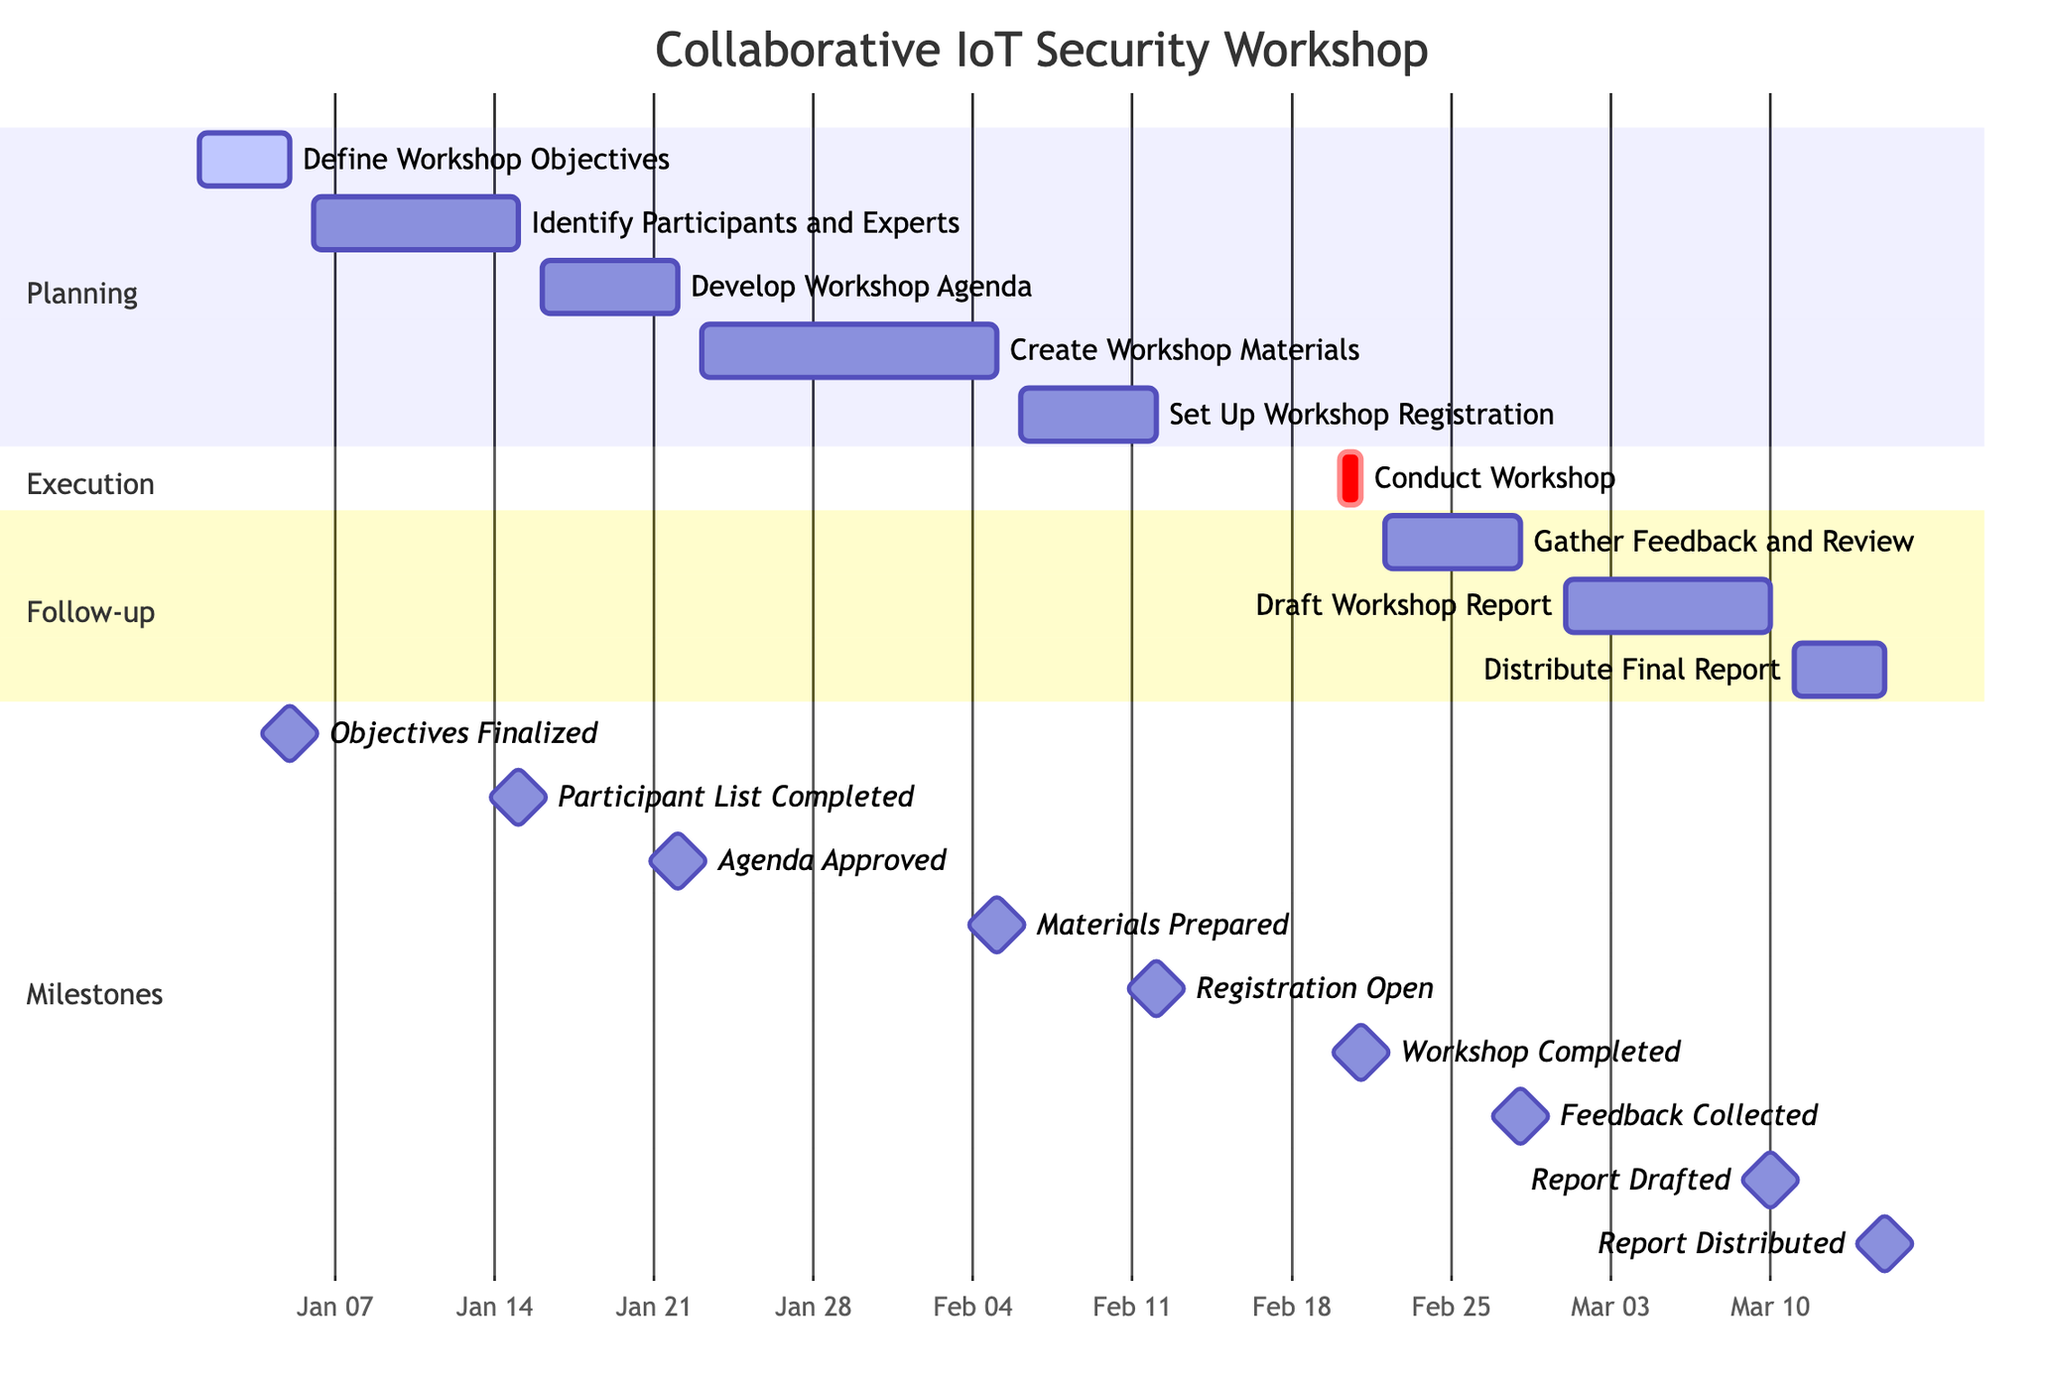What is the name of the project shown in the diagram? The title of the Gantt chart indicates that the project name is "Collaborative IoT Security Workshop".
Answer: Collaborative IoT Security Workshop Who is responsible for developing the workshop agenda? In the tasks section, the task "Develop Workshop Agenda" is assigned to Laura Brown.
Answer: Laura Brown What is the end date of the task "Create Workshop Materials"? The task "Create Workshop Materials" is shown to end on February 5, 2024.
Answer: February 5, 2024 How many tasks are scheduled to be completed before the workshop date? The workshop date is February 20-21, and there are five tasks scheduled to be completed before this date.
Answer: 5 What is the milestone associated with the task of identifying participants? The milestone for the task "Identify Participants and Experts" is "Participant List Completed".
Answer: Participant List Completed Which task has the earliest start date? The task "Define Workshop Objectives" has the earliest start date of January 1, 2024.
Answer: January 1, 2024 How long is the task "Conduct Workshop" scheduled to last? The task "Conduct Workshop" is scheduled for 2 days, from February 20 to February 21, 2024.
Answer: 2 days Which task has the longest overall duration? The task "Create Workshop Materials" has the longest duration, spanning from January 23 to February 5, 2024, totaling 14 days.
Answer: 14 days What is the milestone associated with the final task in the diagram? The final task, "Distribute Final Report", is associated with the milestone "Report Distributed".
Answer: Report Distributed 